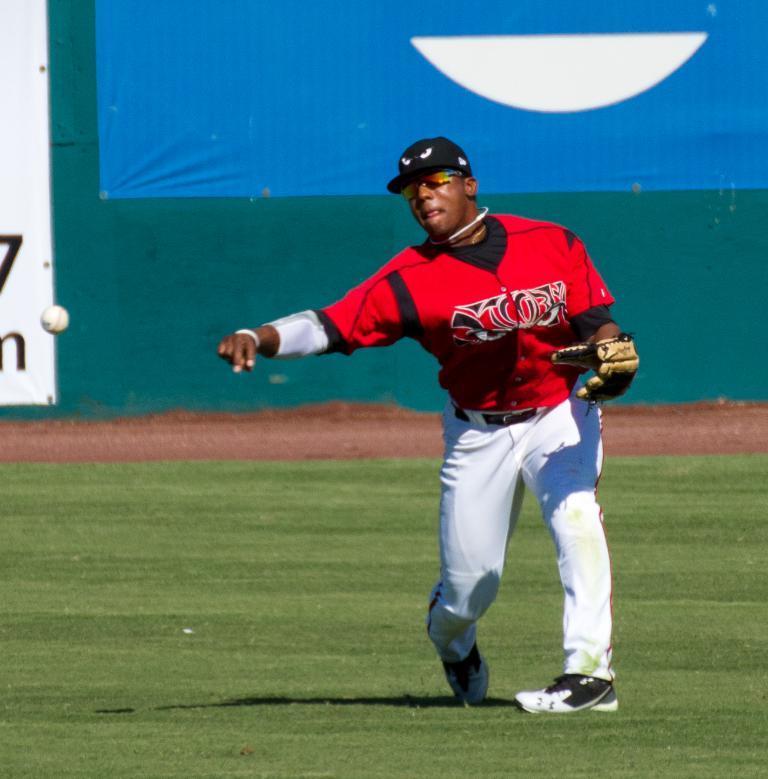Please provide a concise description of this image. In this image there is a base ball player standing on the ground and throwing the ball. Behind him there is a banner. At the bottom there is ground. He is wearing the gloves. 